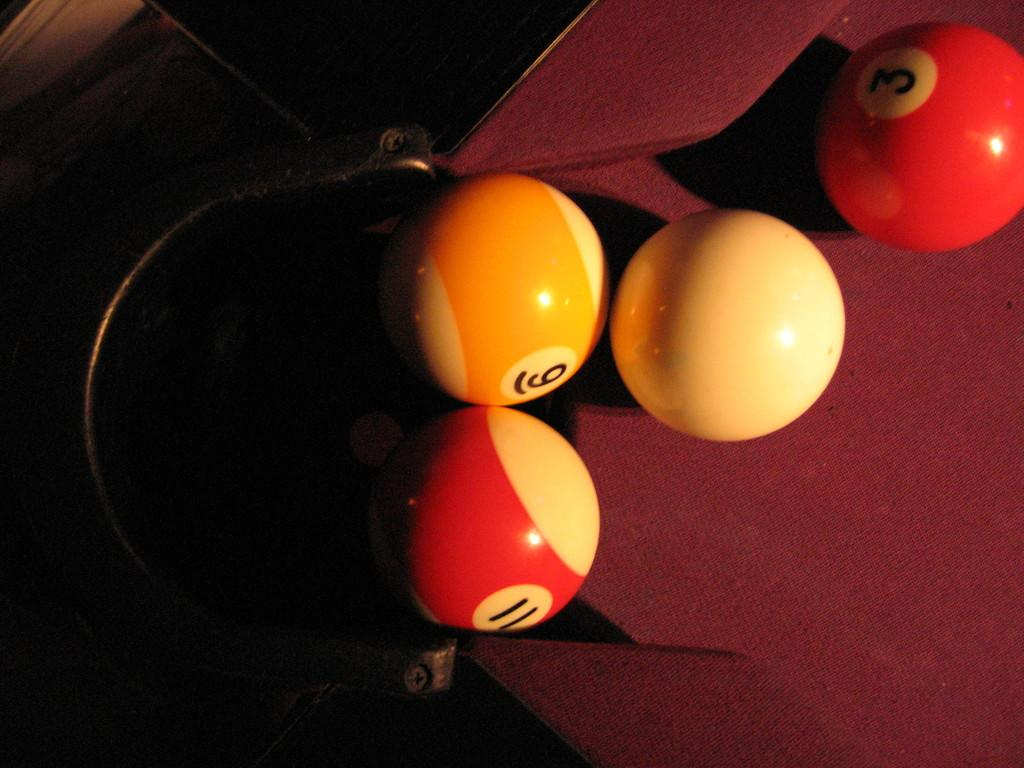<image>
Render a clear and concise summary of the photo. cueball and ball numbers 3, 9, and 11 at a corner of a pool table 